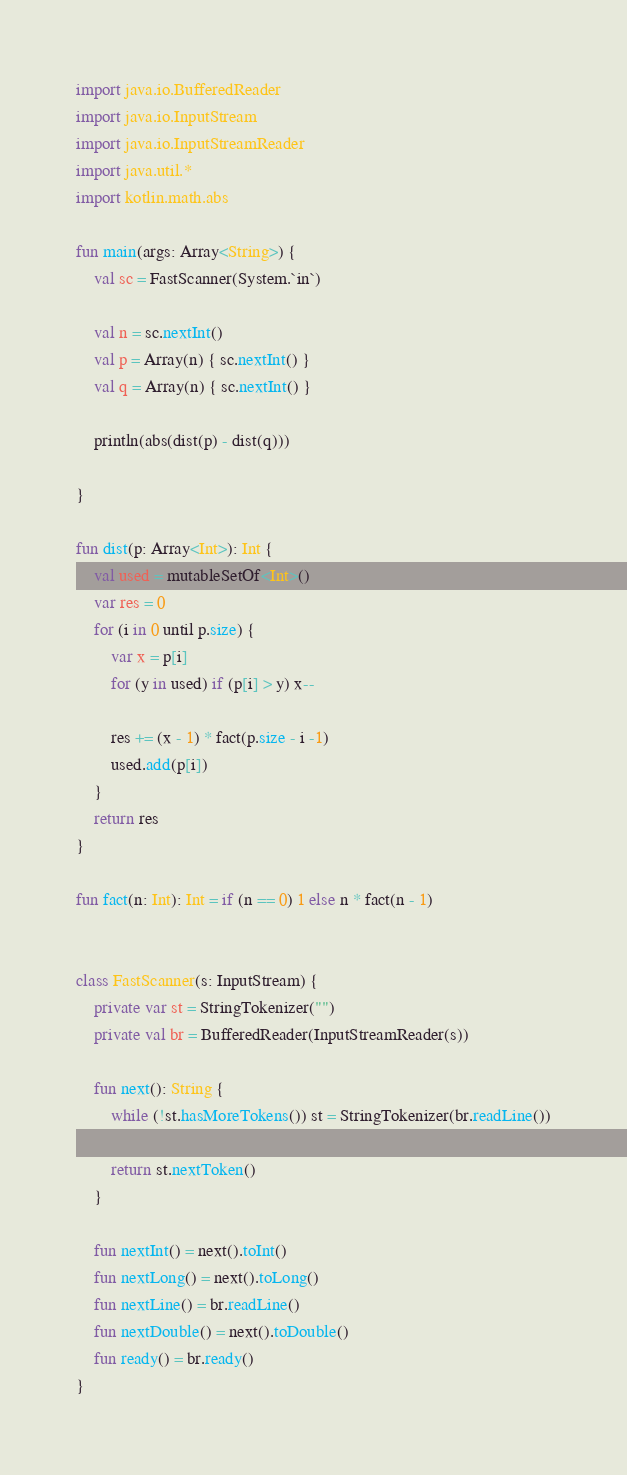<code> <loc_0><loc_0><loc_500><loc_500><_Kotlin_>import java.io.BufferedReader
import java.io.InputStream
import java.io.InputStreamReader
import java.util.*
import kotlin.math.abs

fun main(args: Array<String>) {
    val sc = FastScanner(System.`in`)

    val n = sc.nextInt()
    val p = Array(n) { sc.nextInt() }
    val q = Array(n) { sc.nextInt() }

    println(abs(dist(p) - dist(q)))

}

fun dist(p: Array<Int>): Int {
    val used = mutableSetOf<Int>()
    var res = 0
    for (i in 0 until p.size) {
        var x = p[i]
        for (y in used) if (p[i] > y) x--

        res += (x - 1) * fact(p.size - i -1)
        used.add(p[i])
    }
    return res
}

fun fact(n: Int): Int = if (n == 0) 1 else n * fact(n - 1)


class FastScanner(s: InputStream) {
    private var st = StringTokenizer("")
    private val br = BufferedReader(InputStreamReader(s))

    fun next(): String {
        while (!st.hasMoreTokens()) st = StringTokenizer(br.readLine())

        return st.nextToken()
    }

    fun nextInt() = next().toInt()
    fun nextLong() = next().toLong()
    fun nextLine() = br.readLine()
    fun nextDouble() = next().toDouble()
    fun ready() = br.ready()
}</code> 